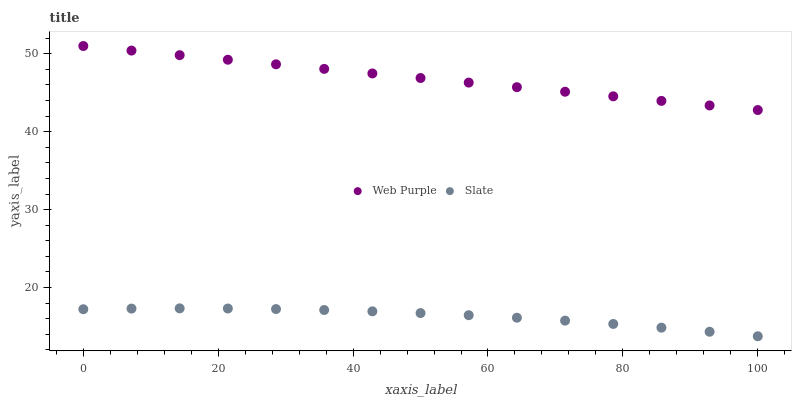Does Slate have the minimum area under the curve?
Answer yes or no. Yes. Does Web Purple have the maximum area under the curve?
Answer yes or no. Yes. Does Slate have the maximum area under the curve?
Answer yes or no. No. Is Web Purple the smoothest?
Answer yes or no. Yes. Is Slate the roughest?
Answer yes or no. Yes. Is Slate the smoothest?
Answer yes or no. No. Does Slate have the lowest value?
Answer yes or no. Yes. Does Web Purple have the highest value?
Answer yes or no. Yes. Does Slate have the highest value?
Answer yes or no. No. Is Slate less than Web Purple?
Answer yes or no. Yes. Is Web Purple greater than Slate?
Answer yes or no. Yes. Does Slate intersect Web Purple?
Answer yes or no. No. 